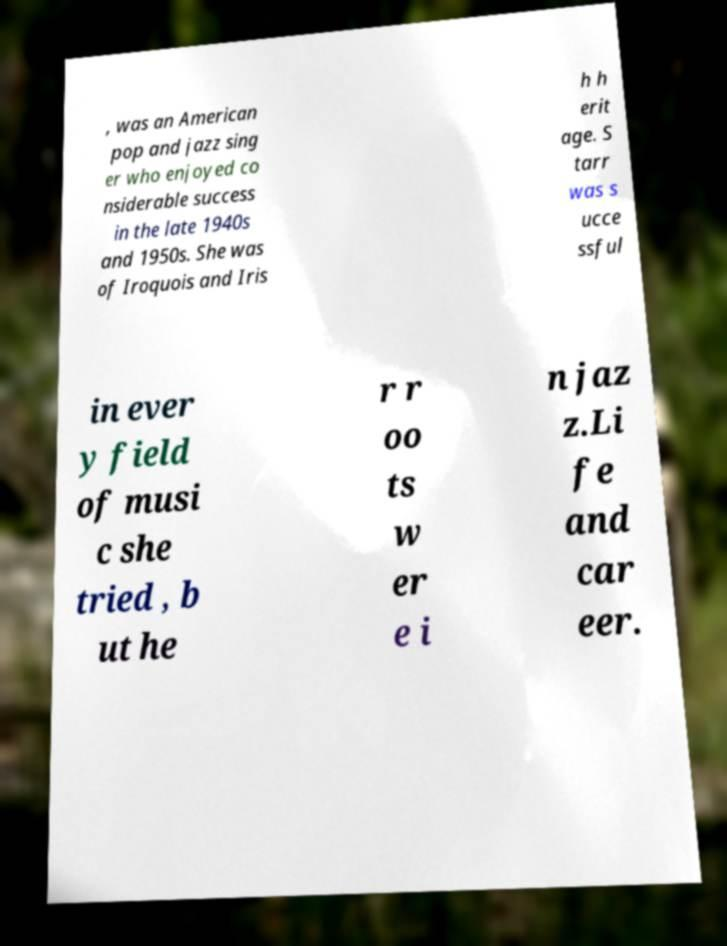Can you read and provide the text displayed in the image?This photo seems to have some interesting text. Can you extract and type it out for me? , was an American pop and jazz sing er who enjoyed co nsiderable success in the late 1940s and 1950s. She was of Iroquois and Iris h h erit age. S tarr was s ucce ssful in ever y field of musi c she tried , b ut he r r oo ts w er e i n jaz z.Li fe and car eer. 